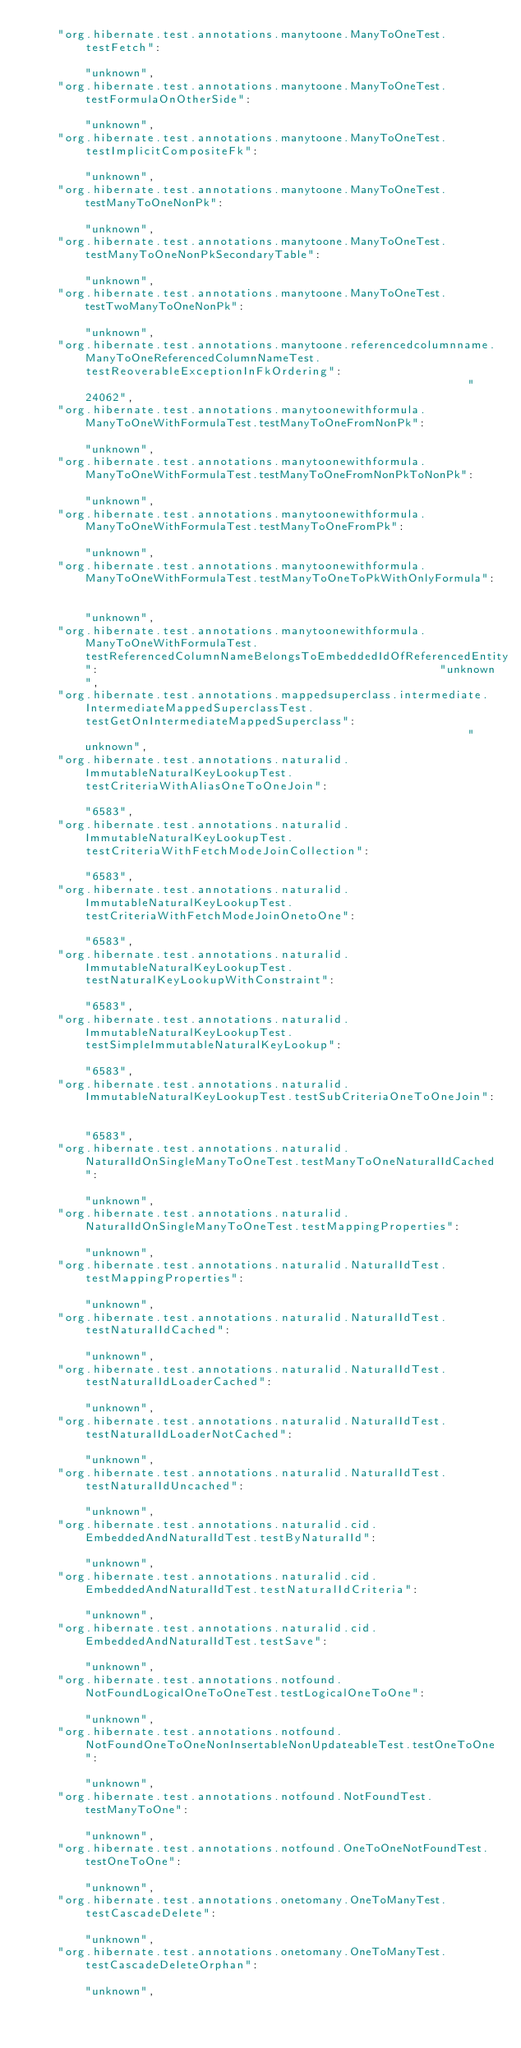<code> <loc_0><loc_0><loc_500><loc_500><_Go_>	"org.hibernate.test.annotations.manytoone.ManyToOneTest.testFetch":                                                                                                                           "unknown",
	"org.hibernate.test.annotations.manytoone.ManyToOneTest.testFormulaOnOtherSide":                                                                                                              "unknown",
	"org.hibernate.test.annotations.manytoone.ManyToOneTest.testImplicitCompositeFk":                                                                                                             "unknown",
	"org.hibernate.test.annotations.manytoone.ManyToOneTest.testManyToOneNonPk":                                                                                                                  "unknown",
	"org.hibernate.test.annotations.manytoone.ManyToOneTest.testManyToOneNonPkSecondaryTable":                                                                                                    "unknown",
	"org.hibernate.test.annotations.manytoone.ManyToOneTest.testTwoManyToOneNonPk":                                                                                                               "unknown",
	"org.hibernate.test.annotations.manytoone.referencedcolumnname.ManyToOneReferencedColumnNameTest.testReoverableExceptionInFkOrdering":                                                        "24062",
	"org.hibernate.test.annotations.manytoonewithformula.ManyToOneWithFormulaTest.testManyToOneFromNonPk":                                                                                        "unknown",
	"org.hibernate.test.annotations.manytoonewithformula.ManyToOneWithFormulaTest.testManyToOneFromNonPkToNonPk":                                                                                 "unknown",
	"org.hibernate.test.annotations.manytoonewithformula.ManyToOneWithFormulaTest.testManyToOneFromPk":                                                                                           "unknown",
	"org.hibernate.test.annotations.manytoonewithformula.ManyToOneWithFormulaTest.testManyToOneToPkWithOnlyFormula":                                                                              "unknown",
	"org.hibernate.test.annotations.manytoonewithformula.ManyToOneWithFormulaTest.testReferencedColumnNameBelongsToEmbeddedIdOfReferencedEntity":                                                 "unknown",
	"org.hibernate.test.annotations.mappedsuperclass.intermediate.IntermediateMappedSuperclassTest.testGetOnIntermediateMappedSuperclass":                                                        "unknown",
	"org.hibernate.test.annotations.naturalid.ImmutableNaturalKeyLookupTest.testCriteriaWithAliasOneToOneJoin":                                                                                   "6583",
	"org.hibernate.test.annotations.naturalid.ImmutableNaturalKeyLookupTest.testCriteriaWithFetchModeJoinCollection":                                                                             "6583",
	"org.hibernate.test.annotations.naturalid.ImmutableNaturalKeyLookupTest.testCriteriaWithFetchModeJoinOnetoOne":                                                                               "6583",
	"org.hibernate.test.annotations.naturalid.ImmutableNaturalKeyLookupTest.testNaturalKeyLookupWithConstraint":                                                                                  "6583",
	"org.hibernate.test.annotations.naturalid.ImmutableNaturalKeyLookupTest.testSimpleImmutableNaturalKeyLookup":                                                                                 "6583",
	"org.hibernate.test.annotations.naturalid.ImmutableNaturalKeyLookupTest.testSubCriteriaOneToOneJoin":                                                                                         "6583",
	"org.hibernate.test.annotations.naturalid.NaturalIdOnSingleManyToOneTest.testManyToOneNaturalIdCached":                                                                                       "unknown",
	"org.hibernate.test.annotations.naturalid.NaturalIdOnSingleManyToOneTest.testMappingProperties":                                                                                              "unknown",
	"org.hibernate.test.annotations.naturalid.NaturalIdTest.testMappingProperties":                                                                                                               "unknown",
	"org.hibernate.test.annotations.naturalid.NaturalIdTest.testNaturalIdCached":                                                                                                                 "unknown",
	"org.hibernate.test.annotations.naturalid.NaturalIdTest.testNaturalIdLoaderCached":                                                                                                           "unknown",
	"org.hibernate.test.annotations.naturalid.NaturalIdTest.testNaturalIdLoaderNotCached":                                                                                                        "unknown",
	"org.hibernate.test.annotations.naturalid.NaturalIdTest.testNaturalIdUncached":                                                                                                               "unknown",
	"org.hibernate.test.annotations.naturalid.cid.EmbeddedAndNaturalIdTest.testByNaturalId":                                                                                                      "unknown",
	"org.hibernate.test.annotations.naturalid.cid.EmbeddedAndNaturalIdTest.testNaturalIdCriteria":                                                                                                "unknown",
	"org.hibernate.test.annotations.naturalid.cid.EmbeddedAndNaturalIdTest.testSave":                                                                                                             "unknown",
	"org.hibernate.test.annotations.notfound.NotFoundLogicalOneToOneTest.testLogicalOneToOne":                                                                                                    "unknown",
	"org.hibernate.test.annotations.notfound.NotFoundOneToOneNonInsertableNonUpdateableTest.testOneToOne":                                                                                        "unknown",
	"org.hibernate.test.annotations.notfound.NotFoundTest.testManyToOne":                                                                                                                         "unknown",
	"org.hibernate.test.annotations.notfound.OneToOneNotFoundTest.testOneToOne":                                                                                                                  "unknown",
	"org.hibernate.test.annotations.onetomany.OneToManyTest.testCascadeDelete":                                                                                                                   "unknown",
	"org.hibernate.test.annotations.onetomany.OneToManyTest.testCascadeDeleteOrphan":                                                                                                             "unknown",</code> 